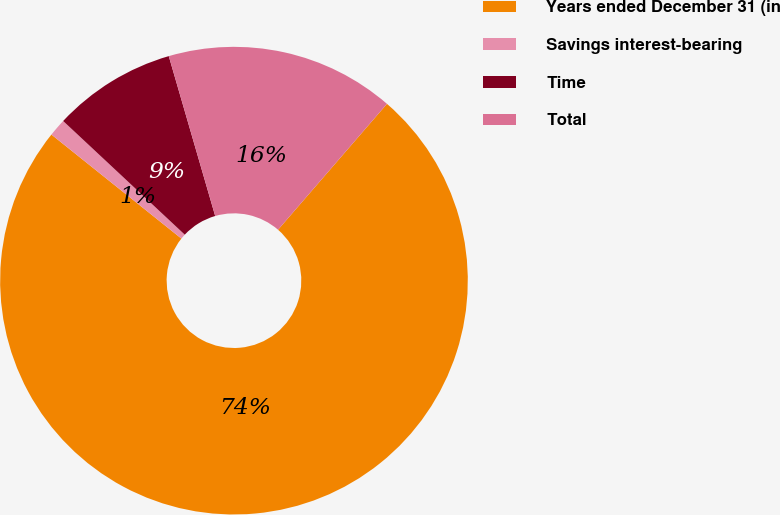Convert chart to OTSL. <chart><loc_0><loc_0><loc_500><loc_500><pie_chart><fcel>Years ended December 31 (in<fcel>Savings interest-bearing<fcel>Time<fcel>Total<nl><fcel>74.39%<fcel>1.22%<fcel>8.54%<fcel>15.85%<nl></chart> 